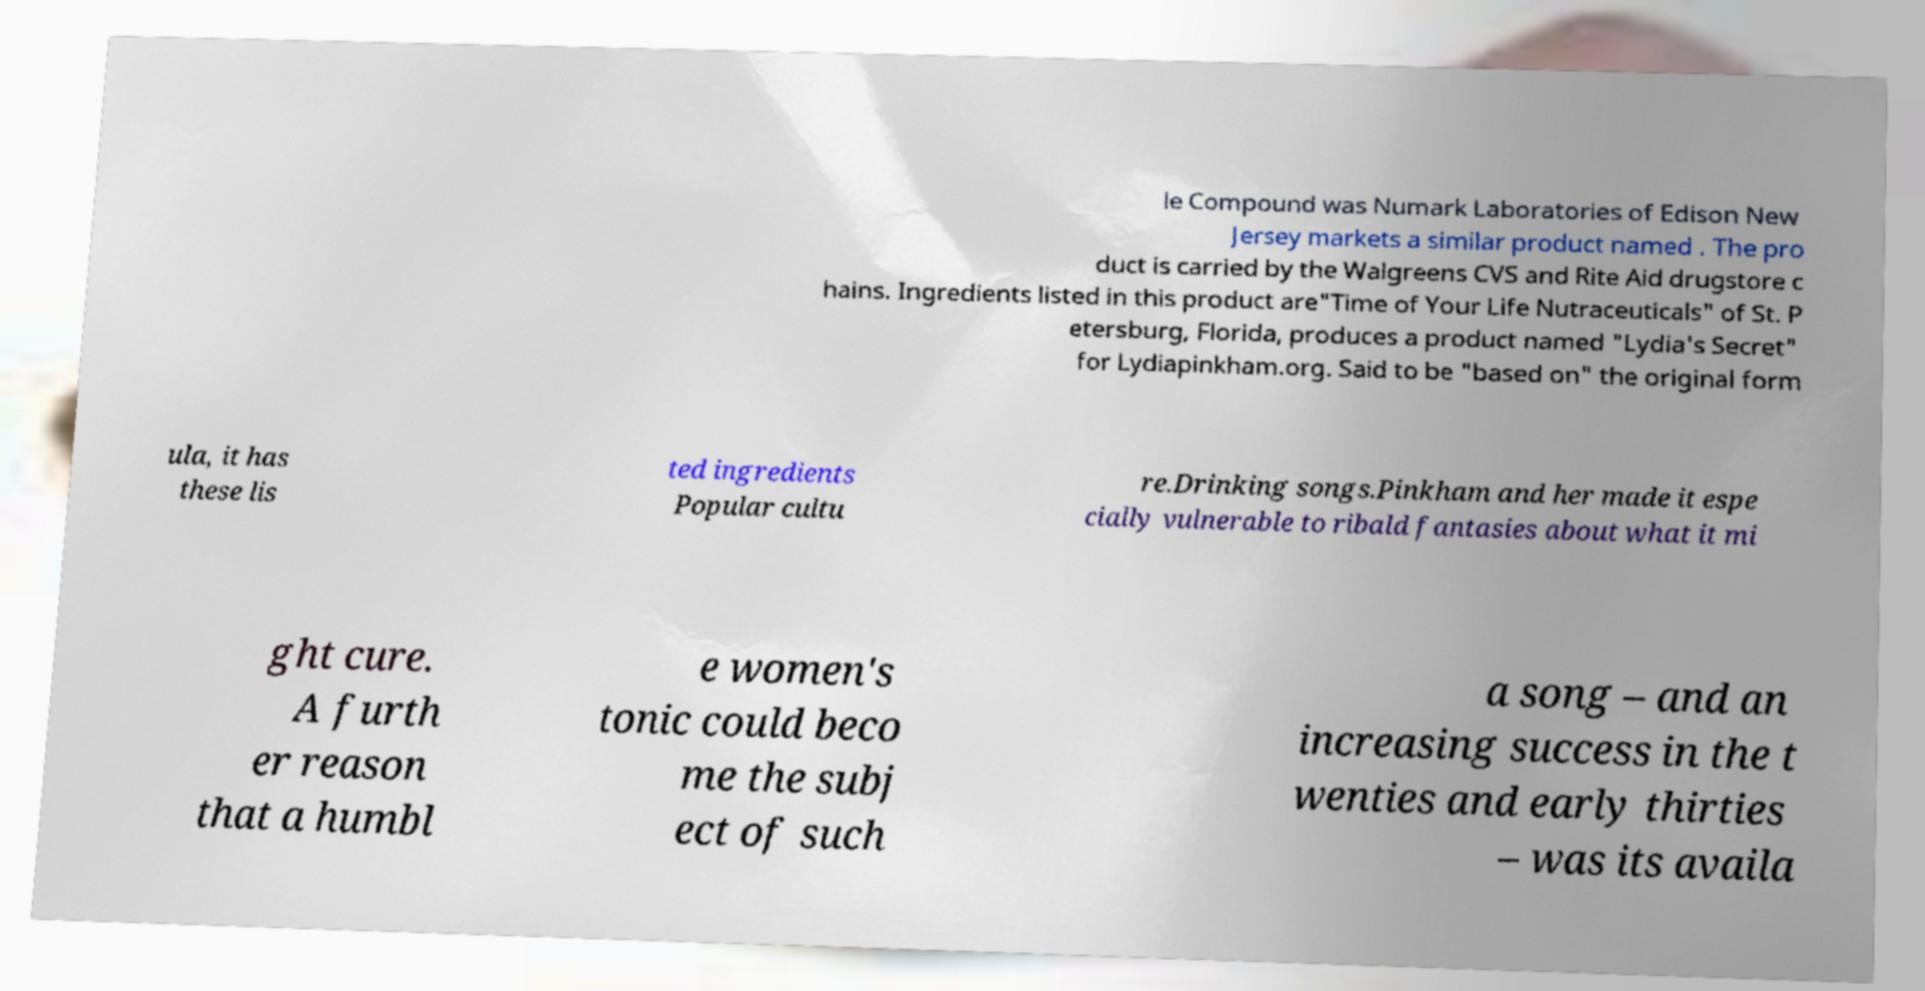Can you accurately transcribe the text from the provided image for me? le Compound was Numark Laboratories of Edison New Jersey markets a similar product named . The pro duct is carried by the Walgreens CVS and Rite Aid drugstore c hains. Ingredients listed in this product are"Time of Your Life Nutraceuticals" of St. P etersburg, Florida, produces a product named "Lydia's Secret" for Lydiapinkham.org. Said to be "based on" the original form ula, it has these lis ted ingredients Popular cultu re.Drinking songs.Pinkham and her made it espe cially vulnerable to ribald fantasies about what it mi ght cure. A furth er reason that a humbl e women's tonic could beco me the subj ect of such a song – and an increasing success in the t wenties and early thirties – was its availa 